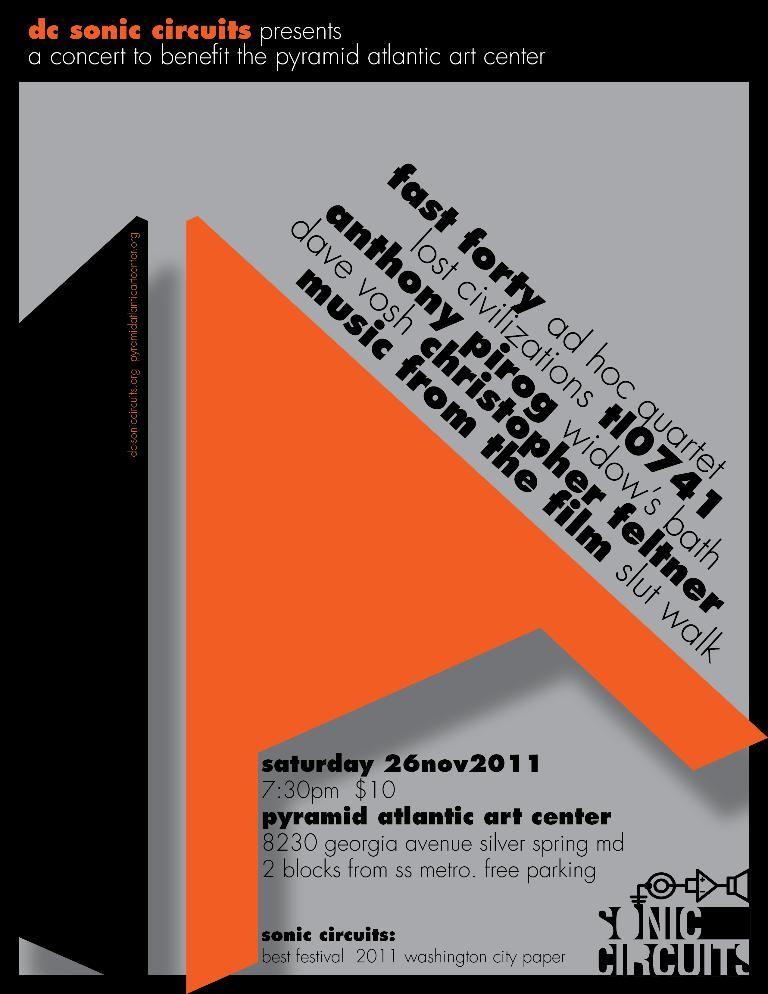<image>
Provide a brief description of the given image. A poster with orange and grey is advertising for Sonic Circuits. 